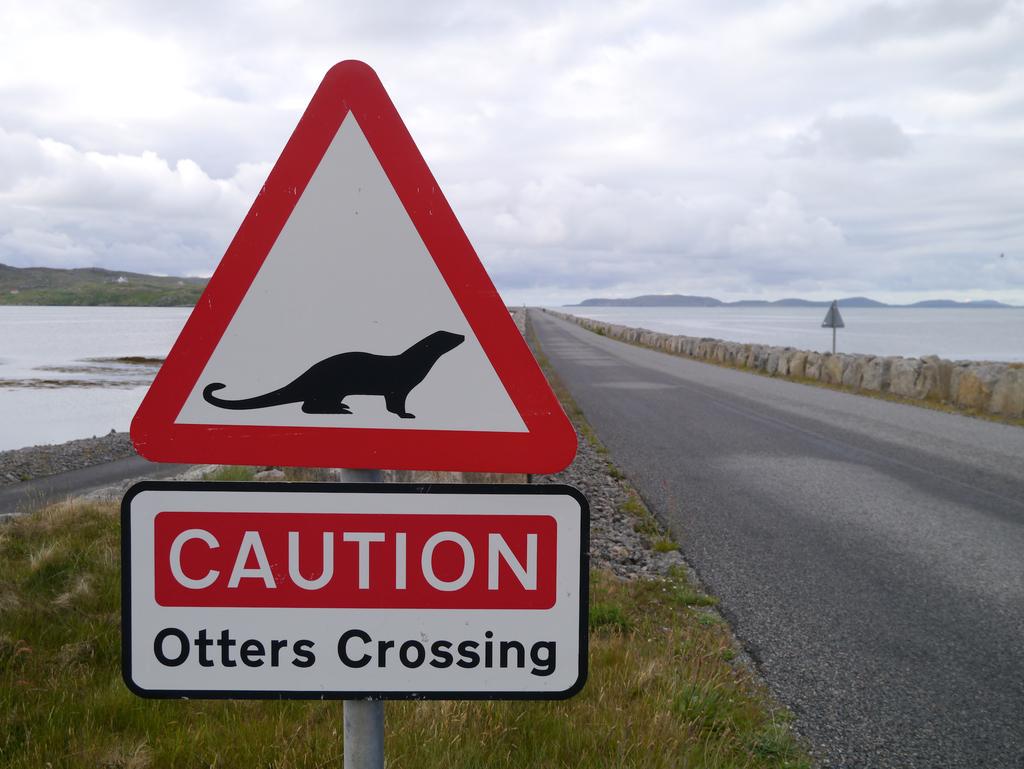What word is in the red?
Make the answer very short. Caution. 